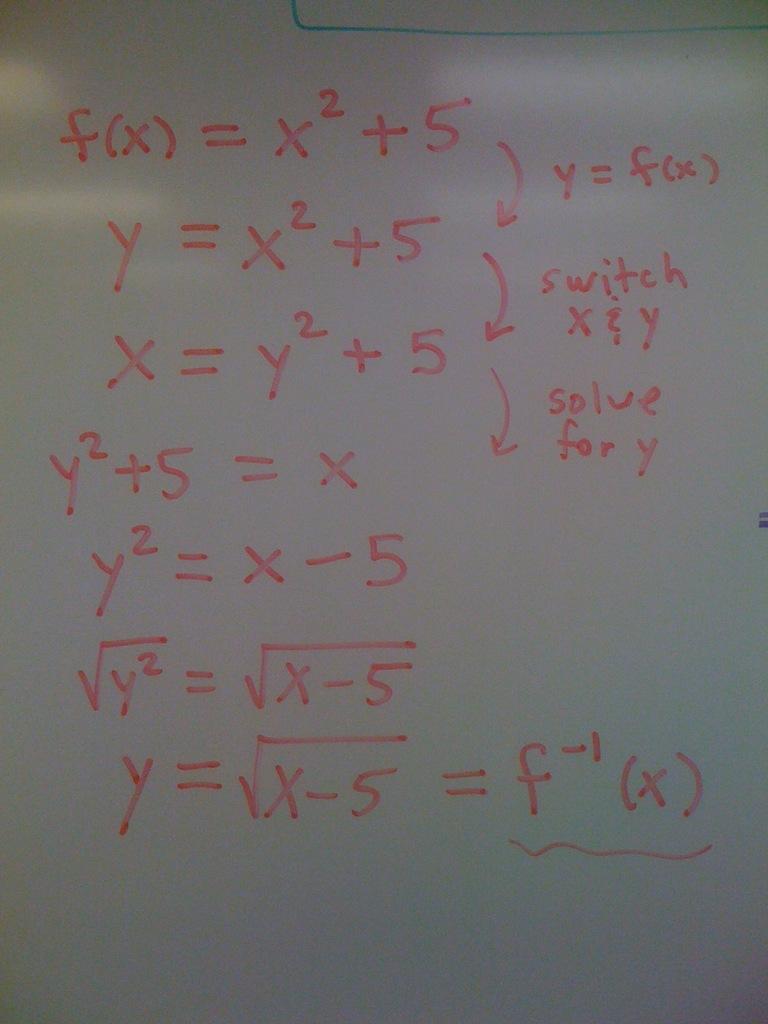What do you solve for?
Provide a short and direct response. Y. What number is above f?
Give a very brief answer. -1. 